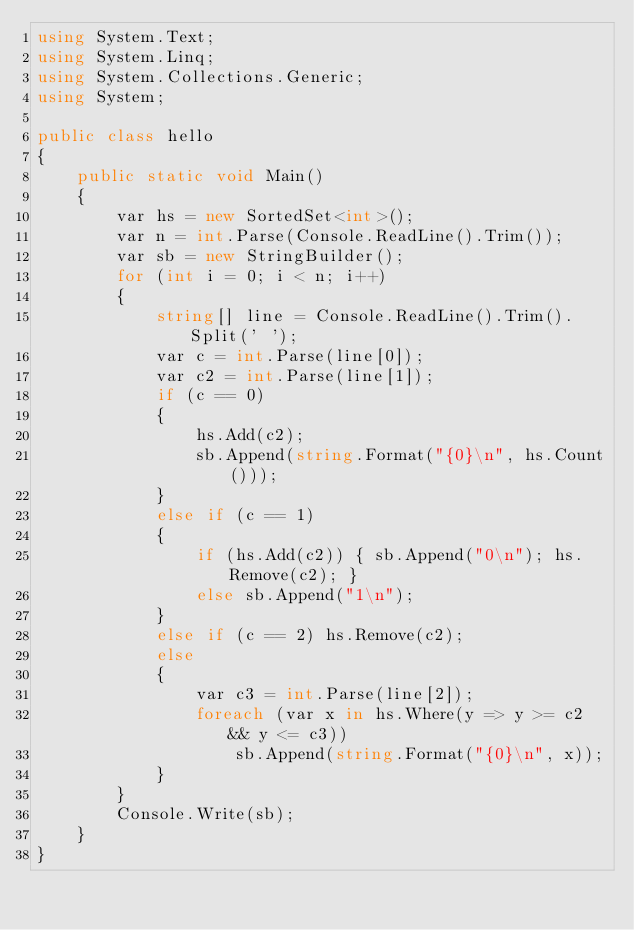<code> <loc_0><loc_0><loc_500><loc_500><_C#_>using System.Text;
using System.Linq;
using System.Collections.Generic;
using System;

public class hello
{
    public static void Main()
    {
        var hs = new SortedSet<int>();
        var n = int.Parse(Console.ReadLine().Trim());
        var sb = new StringBuilder();
        for (int i = 0; i < n; i++)
        {
            string[] line = Console.ReadLine().Trim().Split(' ');
            var c = int.Parse(line[0]);
            var c2 = int.Parse(line[1]);
            if (c == 0)
            {
                hs.Add(c2);
                sb.Append(string.Format("{0}\n", hs.Count()));
            }
            else if (c == 1)
            {
                if (hs.Add(c2)) { sb.Append("0\n"); hs.Remove(c2); }
                else sb.Append("1\n");
            }
            else if (c == 2) hs.Remove(c2);
            else
            {
                var c3 = int.Parse(line[2]);
                foreach (var x in hs.Where(y => y >= c2 && y <= c3))
                    sb.Append(string.Format("{0}\n", x));
            }
        }
        Console.Write(sb);
    }
}



</code> 